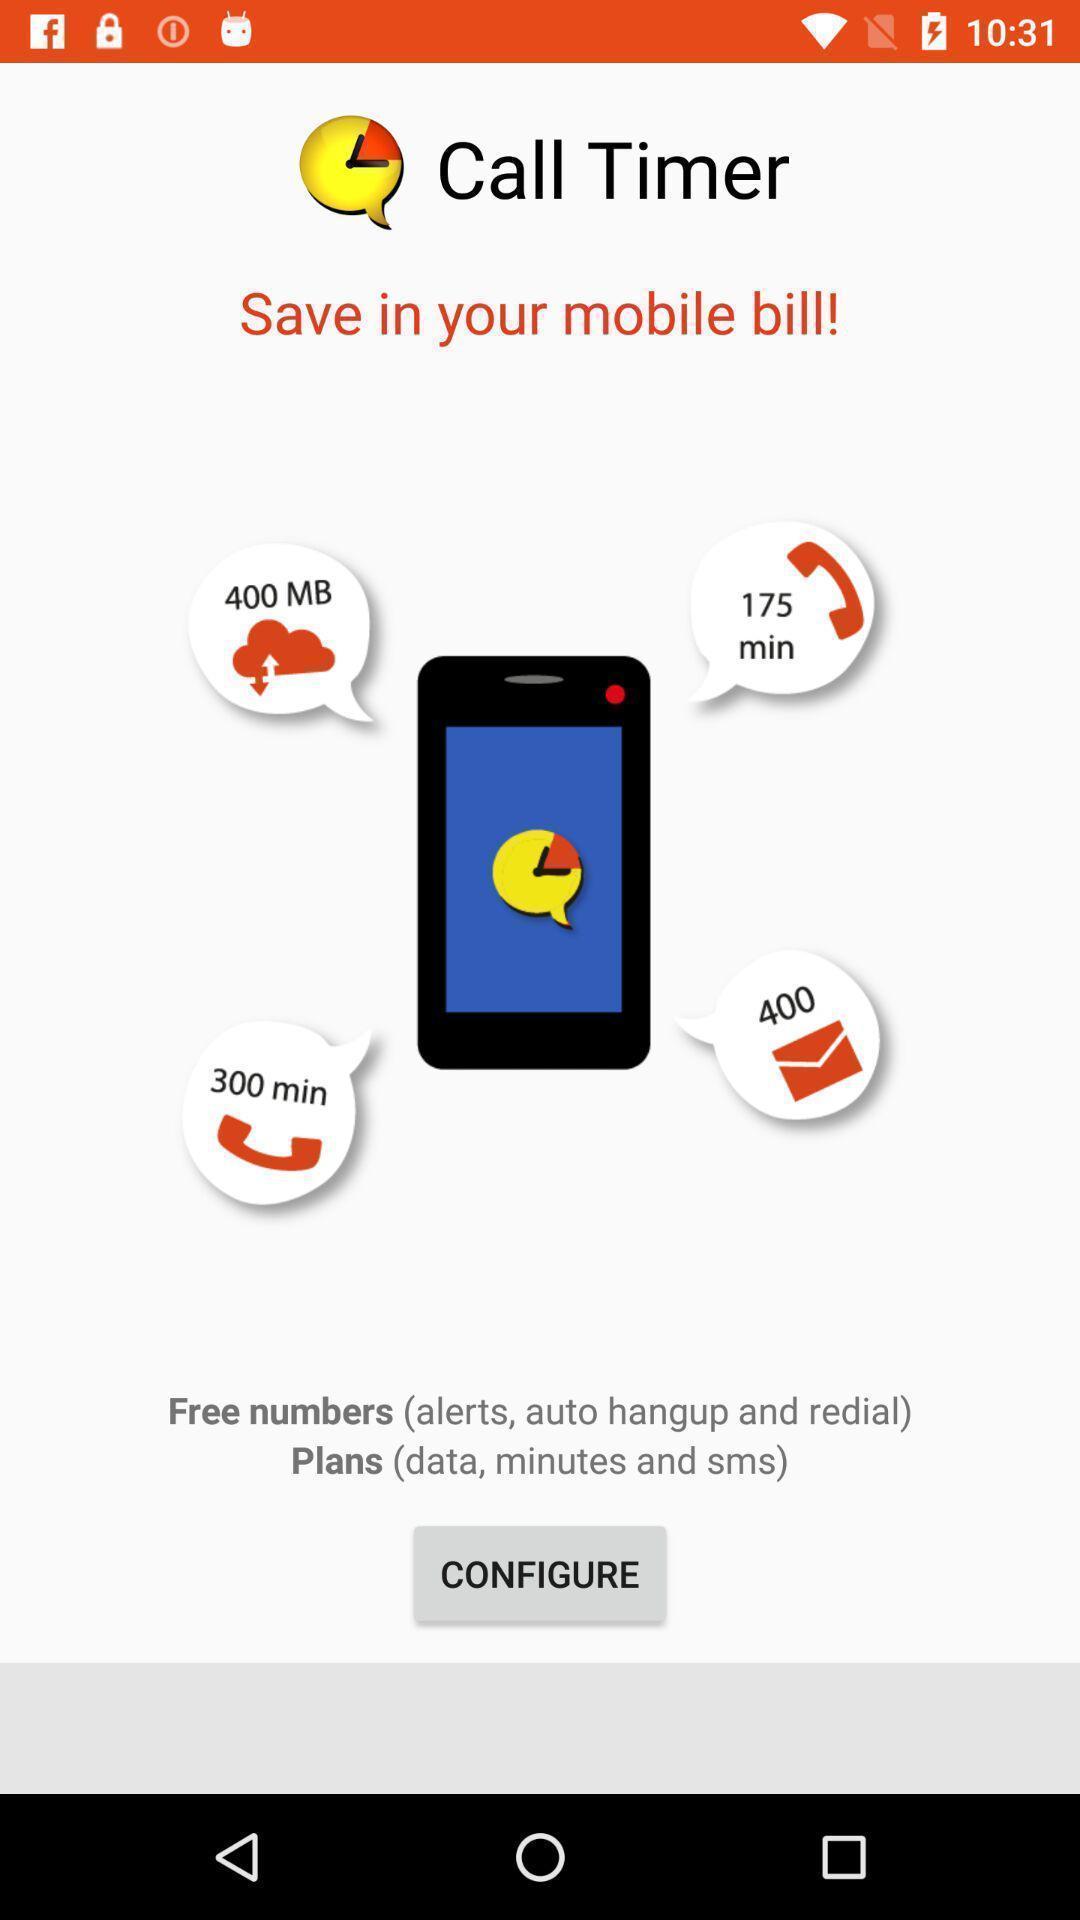Provide a description of this screenshot. Page to configure mobile plans. 